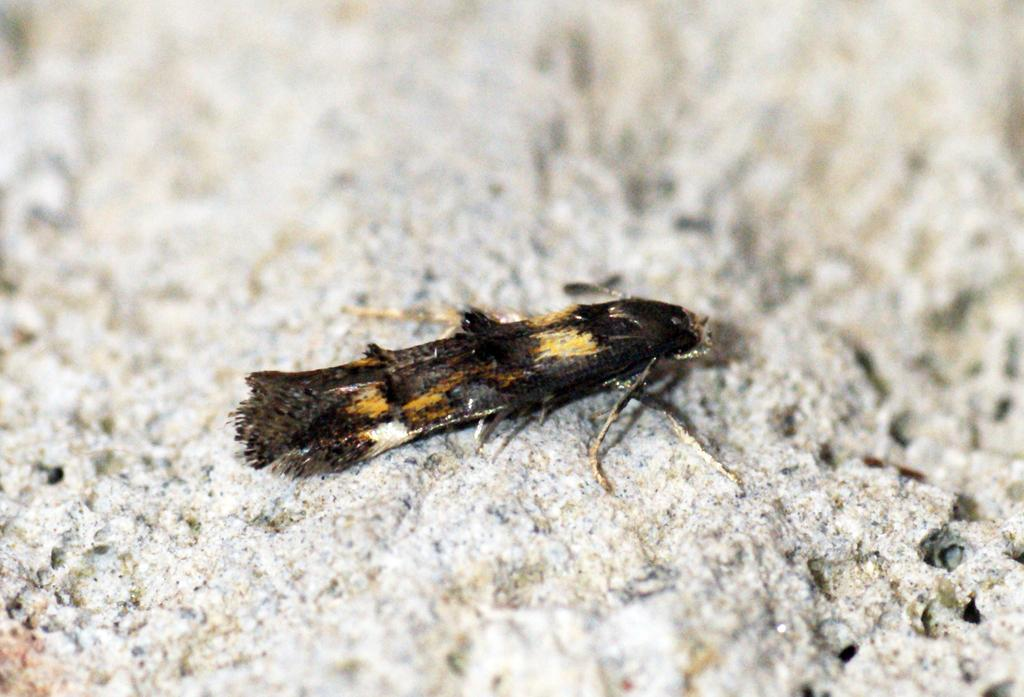What type of creature is present in the image? There is an insect in the image. Can you describe the color of the insect? The insect is brown and black in color. What songs does the queen of the company sing in the image? There is no queen or company present in the image, and therefore no such singing can be observed. 